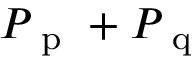<formula> <loc_0><loc_0><loc_500><loc_500>P _ { p } + P _ { q }</formula> 